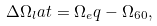Convert formula to latex. <formula><loc_0><loc_0><loc_500><loc_500>\Delta \Omega _ { l } a t = \Omega _ { e } q - \Omega _ { 6 0 } ,</formula> 